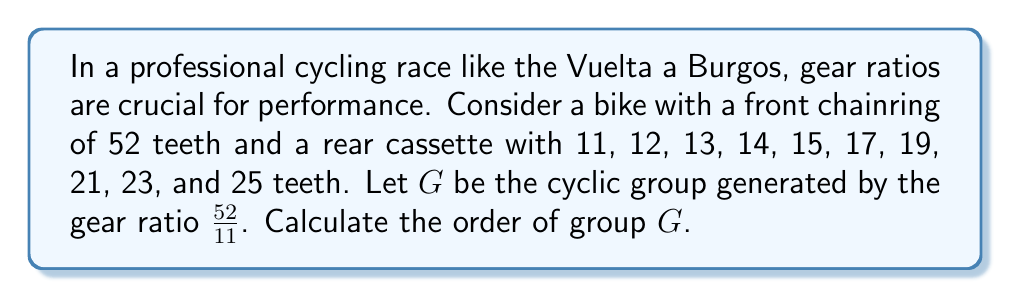Provide a solution to this math problem. To solve this problem, we'll follow these steps:

1) First, we need to understand what the group $G$ represents. Each element in $G$ is of the form $(\frac{52}{11})^n$, where $n$ is an integer.

2) The order of the group is the smallest positive integer $k$ such that $(\frac{52}{11})^k = 1$.

3) This is equivalent to finding the smallest positive integer $k$ such that $\frac{52^k}{11^k} = 1$.

4) This means we need to find the smallest $k$ where $52^k = 11^k$.

5) To solve this, we need to find the least common multiple (LCM) of the multiplicative orders of 52 and 11 modulo each other.

6) $52 \equiv 8 \pmod{11}$
   The order of 8 modulo 11 is 5, because:
   $8^1 \equiv 8 \pmod{11}$
   $8^2 \equiv 9 \pmod{11}$
   $8^3 \equiv 6 \pmod{11}$
   $8^4 \equiv 4 \pmod{11}$
   $8^5 \equiv 1 \pmod{11}$

7) $11 \equiv 11 \pmod{52}$
   The order of 11 modulo 52 is 52, as 11 and 52 are coprime.

8) Therefore, the order of the group $G$ is $LCM(5, 52) = 260$.
Answer: The order of the cyclic group $G$ is 260. 